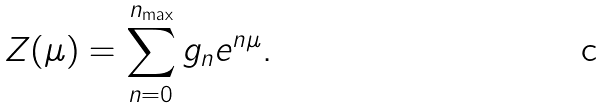<formula> <loc_0><loc_0><loc_500><loc_500>Z ( \mu ) = \sum _ { n = 0 } ^ { n _ { \max } } g _ { n } e ^ { n \mu } .</formula> 